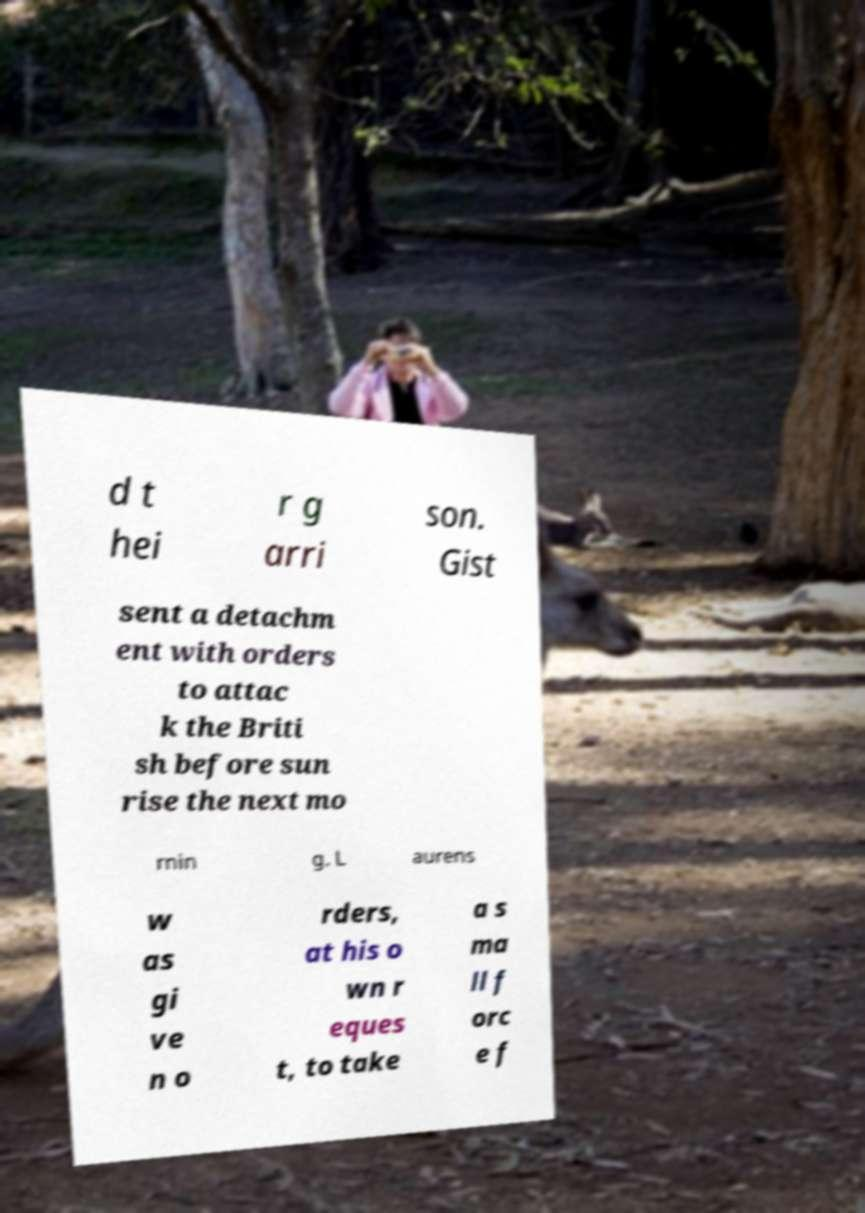What messages or text are displayed in this image? I need them in a readable, typed format. d t hei r g arri son. Gist sent a detachm ent with orders to attac k the Briti sh before sun rise the next mo rnin g. L aurens w as gi ve n o rders, at his o wn r eques t, to take a s ma ll f orc e f 